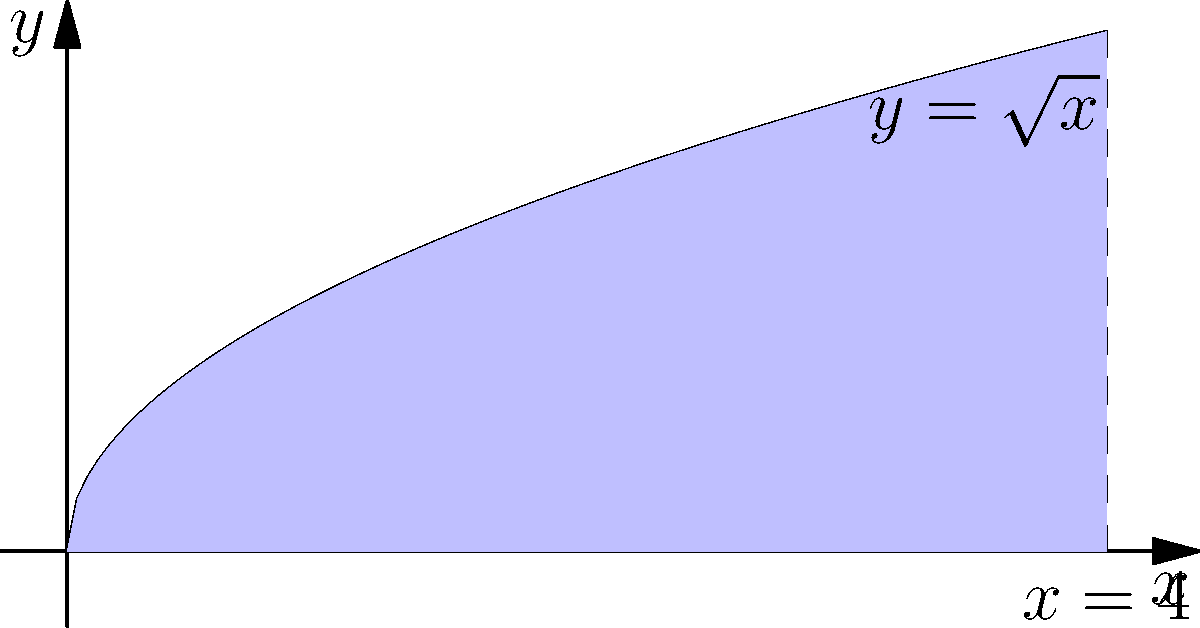As a meticulous professional responsible for accurate information dissemination, you need to calculate the volume of a solid obtained by rotating the region bounded by $y = \sqrt{x}$, $y = 0$, and $x = 4$ around the x-axis. What is the volume of this solid? To find the volume of the solid, we'll use the disk method:

1) The volume is given by the formula: $V = \pi \int_a^b [f(x)]^2 dx$

2) In this case, $f(x) = \sqrt{x}$, $a = 0$, and $b = 4$

3) Substituting into the formula:
   $V = \pi \int_0^4 (\sqrt{x})^2 dx = \pi \int_0^4 x dx$

4) Integrate:
   $V = \pi [\frac{1}{2}x^2]_0^4$

5) Evaluate the bounds:
   $V = \pi (\frac{1}{2}(4^2) - \frac{1}{2}(0^2)) = \pi (8 - 0) = 8\pi$

6) Therefore, the volume of the solid is $8\pi$ cubic units.
Answer: $8\pi$ cubic units 